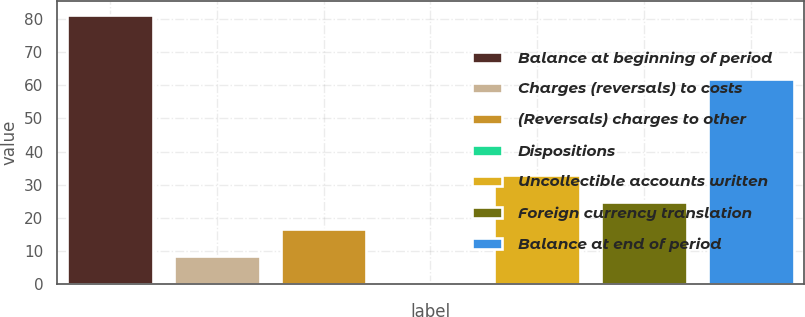<chart> <loc_0><loc_0><loc_500><loc_500><bar_chart><fcel>Balance at beginning of period<fcel>Charges (reversals) to costs<fcel>(Reversals) charges to other<fcel>Dispositions<fcel>Uncollectible accounts written<fcel>Foreign currency translation<fcel>Balance at end of period<nl><fcel>81.3<fcel>8.58<fcel>16.66<fcel>0.5<fcel>32.82<fcel>24.74<fcel>61.8<nl></chart> 